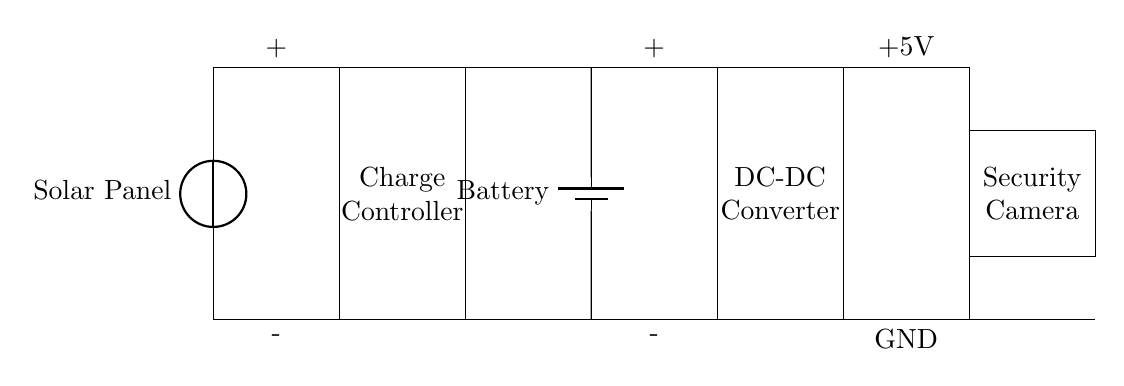What is the power source for this circuit? The power source in this circuit is the solar panel, which converts sunlight into electrical energy.
Answer: solar panel What component regulates the charging process? The charge controller is the component responsible for regulating the charging process to prevent overcharging of the battery.
Answer: charge controller What is the voltage output for the security camera? The voltage output for the security camera is 5 volts, as indicated at the output terminal of the DC-DC converter.
Answer: 5 volts How many main components are there in this circuit? There are five main components in this circuit: solar panel, charge controller, battery, DC-DC converter, and security camera.
Answer: five What is the purpose of the DC-DC converter in this circuit? The DC-DC converter adjusts the voltage from the battery (usually higher) to a stable lower output, specifically 5 volts, suitable for the security camera.
Answer: adjust voltage What happens if the battery becomes fully charged? If the battery becomes fully charged, the charge controller will stop the current flow from the solar panel to prevent overcharging.
Answer: stops charging 